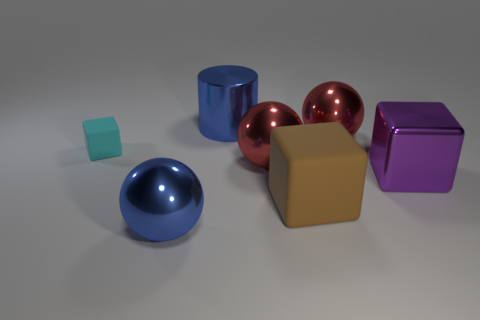How many other objects are the same size as the purple cube?
Provide a succinct answer. 5. There is a small object that is the same shape as the big rubber thing; what is it made of?
Your response must be concise. Rubber. There is a blue thing that is in front of the large blue thing behind the blue shiny thing that is left of the big cylinder; what is its material?
Offer a very short reply. Metal. There is another object that is the same material as the brown thing; what is its size?
Provide a succinct answer. Small. Is there anything else that is the same color as the shiny cube?
Your answer should be compact. No. Does the shiny sphere behind the cyan cube have the same color as the rubber block right of the small cyan rubber object?
Make the answer very short. No. There is a large sphere that is on the left side of the big cylinder; what color is it?
Offer a terse response. Blue. Is the size of the ball in front of the brown rubber thing the same as the brown matte thing?
Your answer should be very brief. Yes. Is the number of red metallic balls less than the number of cyan matte things?
Offer a very short reply. No. There is a large thing that is the same color as the cylinder; what is its shape?
Make the answer very short. Sphere. 